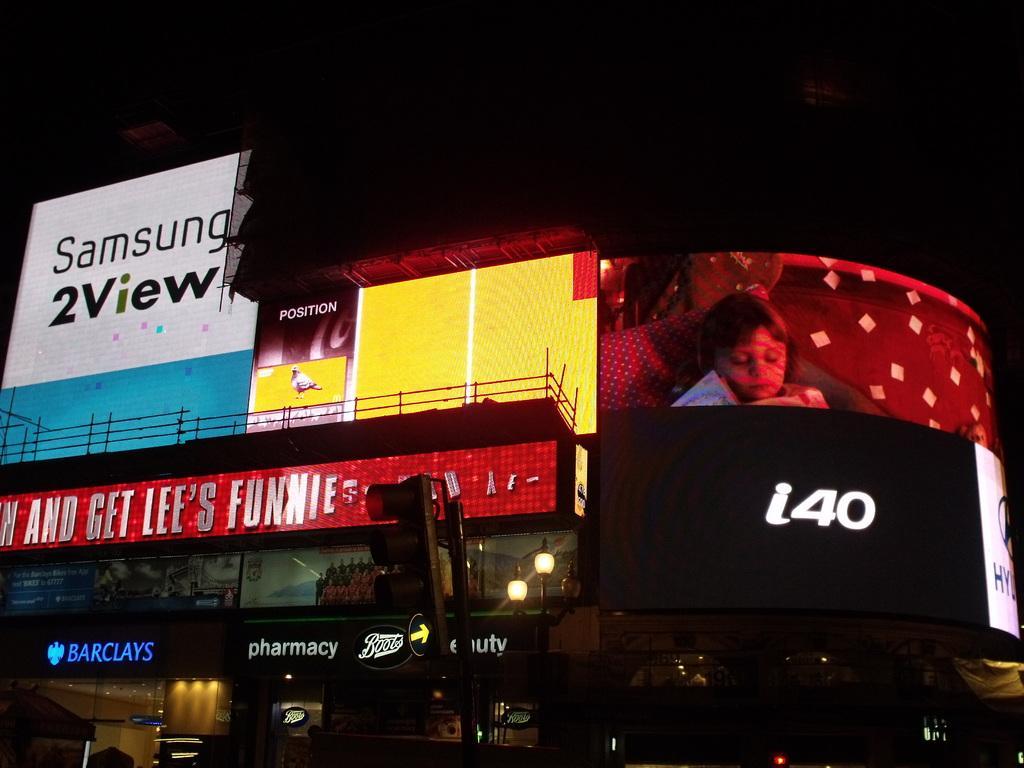In one or two sentences, can you explain what this image depicts? In this image we can see a building. On the building we can see many advertising boards. On the boards we can see the text. In front of the building we can see a traffic pole and lights. At the top the background is dark. 